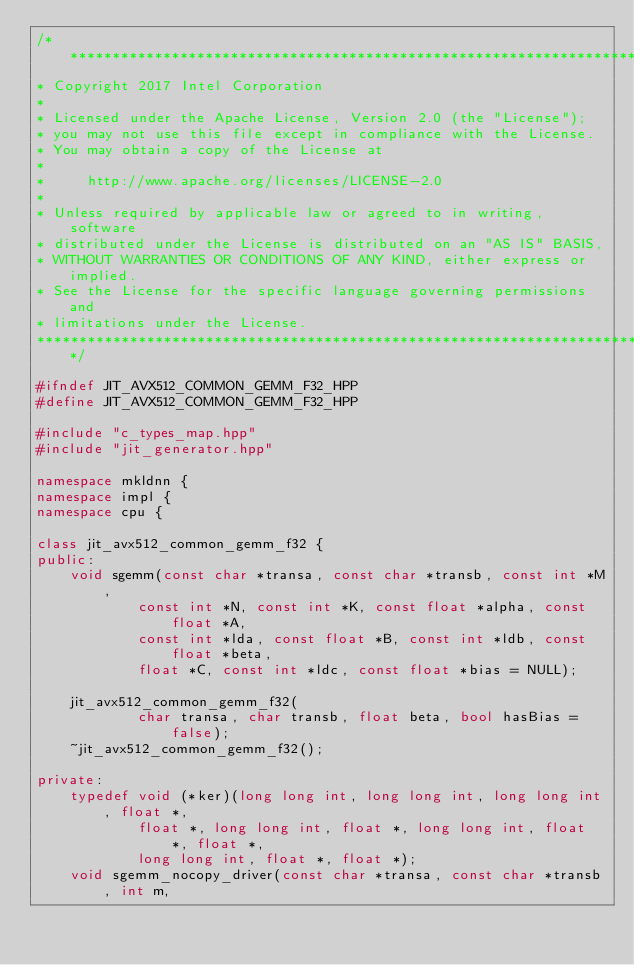Convert code to text. <code><loc_0><loc_0><loc_500><loc_500><_C++_>/*******************************************************************************
* Copyright 2017 Intel Corporation
*
* Licensed under the Apache License, Version 2.0 (the "License");
* you may not use this file except in compliance with the License.
* You may obtain a copy of the License at
*
*     http://www.apache.org/licenses/LICENSE-2.0
*
* Unless required by applicable law or agreed to in writing, software
* distributed under the License is distributed on an "AS IS" BASIS,
* WITHOUT WARRANTIES OR CONDITIONS OF ANY KIND, either express or implied.
* See the License for the specific language governing permissions and
* limitations under the License.
*******************************************************************************/

#ifndef JIT_AVX512_COMMON_GEMM_F32_HPP
#define JIT_AVX512_COMMON_GEMM_F32_HPP

#include "c_types_map.hpp"
#include "jit_generator.hpp"

namespace mkldnn {
namespace impl {
namespace cpu {

class jit_avx512_common_gemm_f32 {
public:
    void sgemm(const char *transa, const char *transb, const int *M,
            const int *N, const int *K, const float *alpha, const float *A,
            const int *lda, const float *B, const int *ldb, const float *beta,
            float *C, const int *ldc, const float *bias = NULL);

    jit_avx512_common_gemm_f32(
            char transa, char transb, float beta, bool hasBias = false);
    ~jit_avx512_common_gemm_f32();

private:
    typedef void (*ker)(long long int, long long int, long long int, float *,
            float *, long long int, float *, long long int, float *, float *,
            long long int, float *, float *);
    void sgemm_nocopy_driver(const char *transa, const char *transb, int m,</code> 